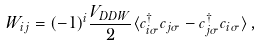Convert formula to latex. <formula><loc_0><loc_0><loc_500><loc_500>W _ { i j } = ( - 1 ) ^ { i } \frac { V _ { D D W } } { 2 } \langle c _ { { i } \sigma } ^ { \dagger } c _ { { j } \sigma } - c _ { { j } \sigma } ^ { \dagger } c _ { { i } \sigma } \rangle \, ,</formula> 